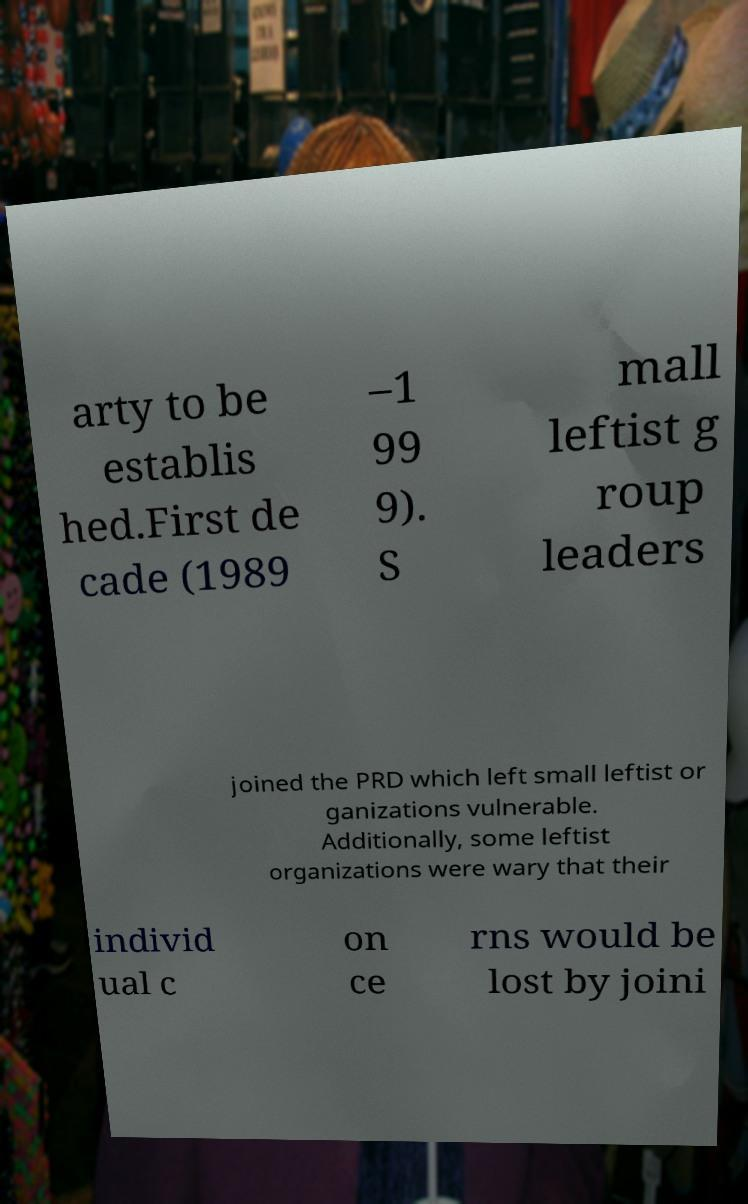Please read and relay the text visible in this image. What does it say? arty to be establis hed.First de cade (1989 –1 99 9). S mall leftist g roup leaders joined the PRD which left small leftist or ganizations vulnerable. Additionally, some leftist organizations were wary that their individ ual c on ce rns would be lost by joini 